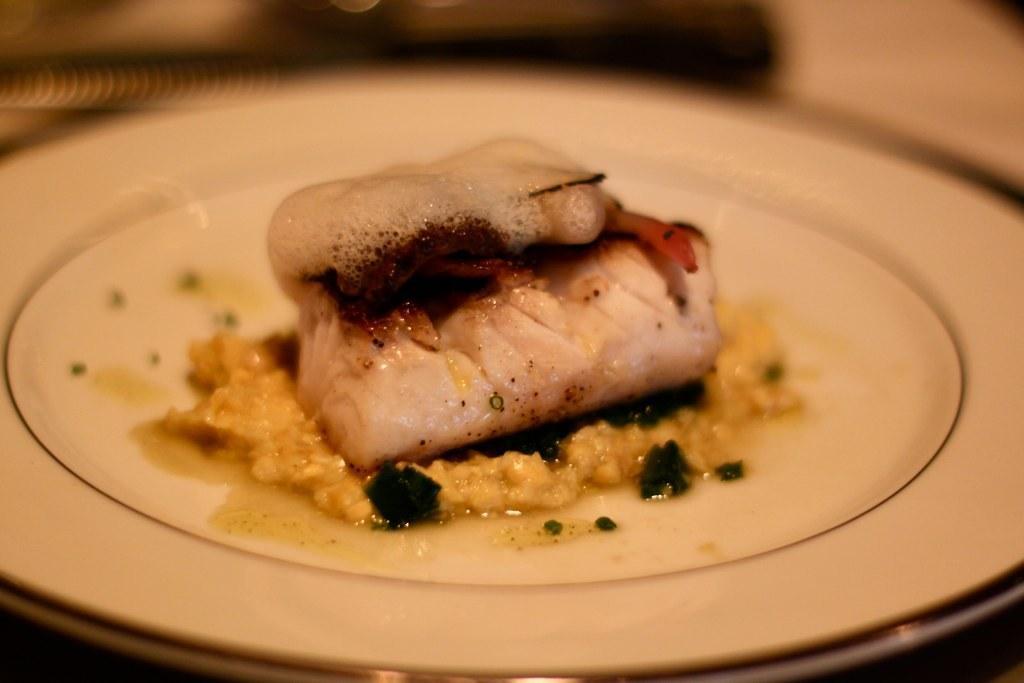How would you summarize this image in a sentence or two? In this picture I can see a food item on white color plate. 